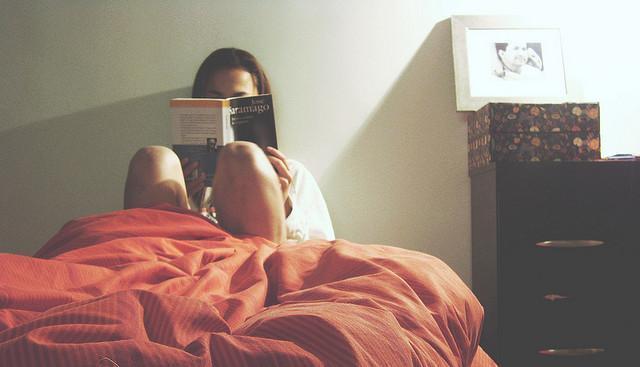How many people are shown this picture?
Give a very brief answer. 1. How many framed pictures can be seen?
Give a very brief answer. 1. 